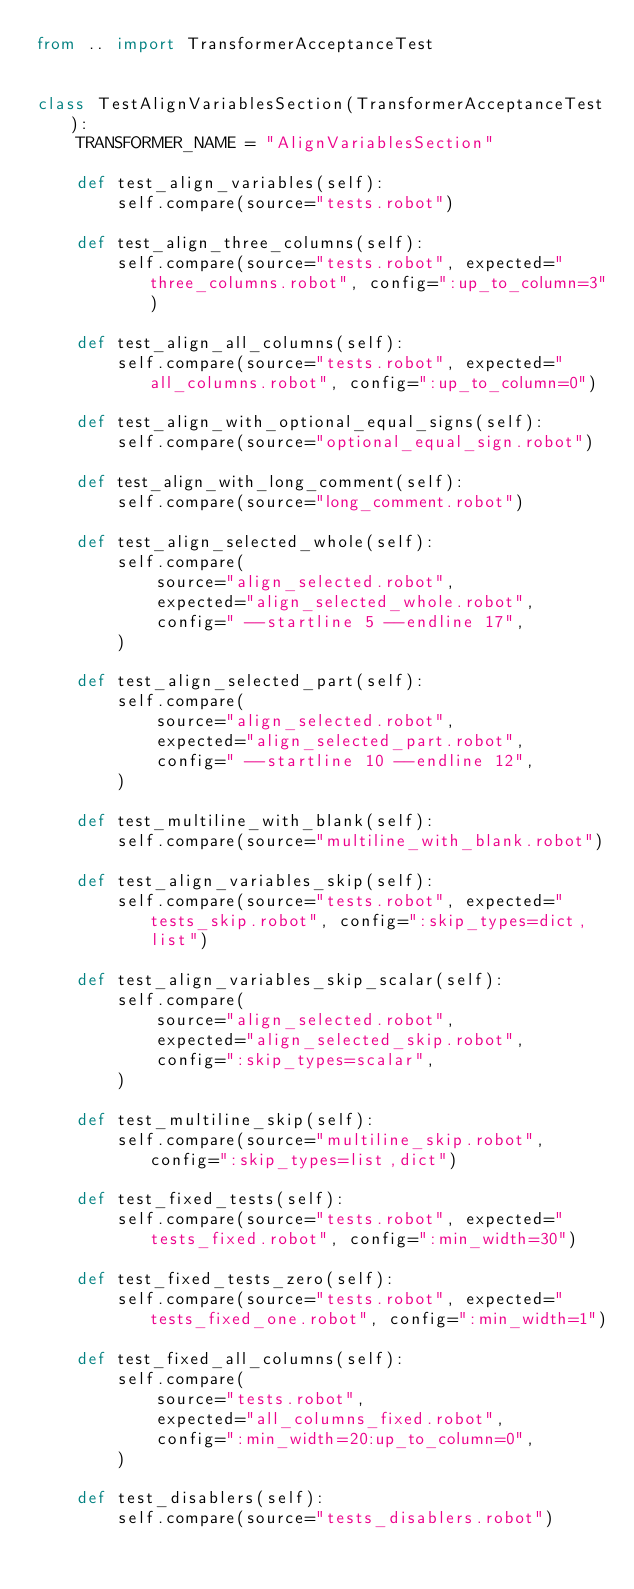<code> <loc_0><loc_0><loc_500><loc_500><_Python_>from .. import TransformerAcceptanceTest


class TestAlignVariablesSection(TransformerAcceptanceTest):
    TRANSFORMER_NAME = "AlignVariablesSection"

    def test_align_variables(self):
        self.compare(source="tests.robot")

    def test_align_three_columns(self):
        self.compare(source="tests.robot", expected="three_columns.robot", config=":up_to_column=3")

    def test_align_all_columns(self):
        self.compare(source="tests.robot", expected="all_columns.robot", config=":up_to_column=0")

    def test_align_with_optional_equal_signs(self):
        self.compare(source="optional_equal_sign.robot")

    def test_align_with_long_comment(self):
        self.compare(source="long_comment.robot")

    def test_align_selected_whole(self):
        self.compare(
            source="align_selected.robot",
            expected="align_selected_whole.robot",
            config=" --startline 5 --endline 17",
        )

    def test_align_selected_part(self):
        self.compare(
            source="align_selected.robot",
            expected="align_selected_part.robot",
            config=" --startline 10 --endline 12",
        )

    def test_multiline_with_blank(self):
        self.compare(source="multiline_with_blank.robot")

    def test_align_variables_skip(self):
        self.compare(source="tests.robot", expected="tests_skip.robot", config=":skip_types=dict,list")

    def test_align_variables_skip_scalar(self):
        self.compare(
            source="align_selected.robot",
            expected="align_selected_skip.robot",
            config=":skip_types=scalar",
        )

    def test_multiline_skip(self):
        self.compare(source="multiline_skip.robot", config=":skip_types=list,dict")

    def test_fixed_tests(self):
        self.compare(source="tests.robot", expected="tests_fixed.robot", config=":min_width=30")

    def test_fixed_tests_zero(self):
        self.compare(source="tests.robot", expected="tests_fixed_one.robot", config=":min_width=1")

    def test_fixed_all_columns(self):
        self.compare(
            source="tests.robot",
            expected="all_columns_fixed.robot",
            config=":min_width=20:up_to_column=0",
        )

    def test_disablers(self):
        self.compare(source="tests_disablers.robot")
</code> 